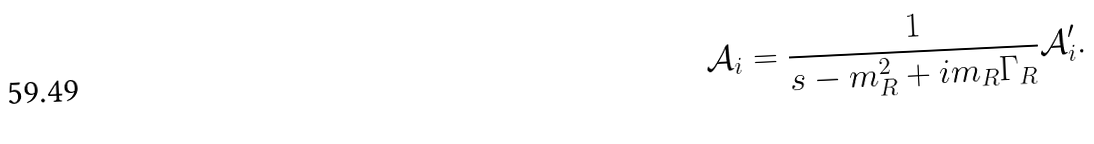Convert formula to latex. <formula><loc_0><loc_0><loc_500><loc_500>\mathcal { A } _ { i } = \frac { 1 } { s - m _ { R } ^ { 2 } + i m _ { R } \Gamma _ { R } } \mathcal { A } ^ { \prime } _ { i } .</formula> 